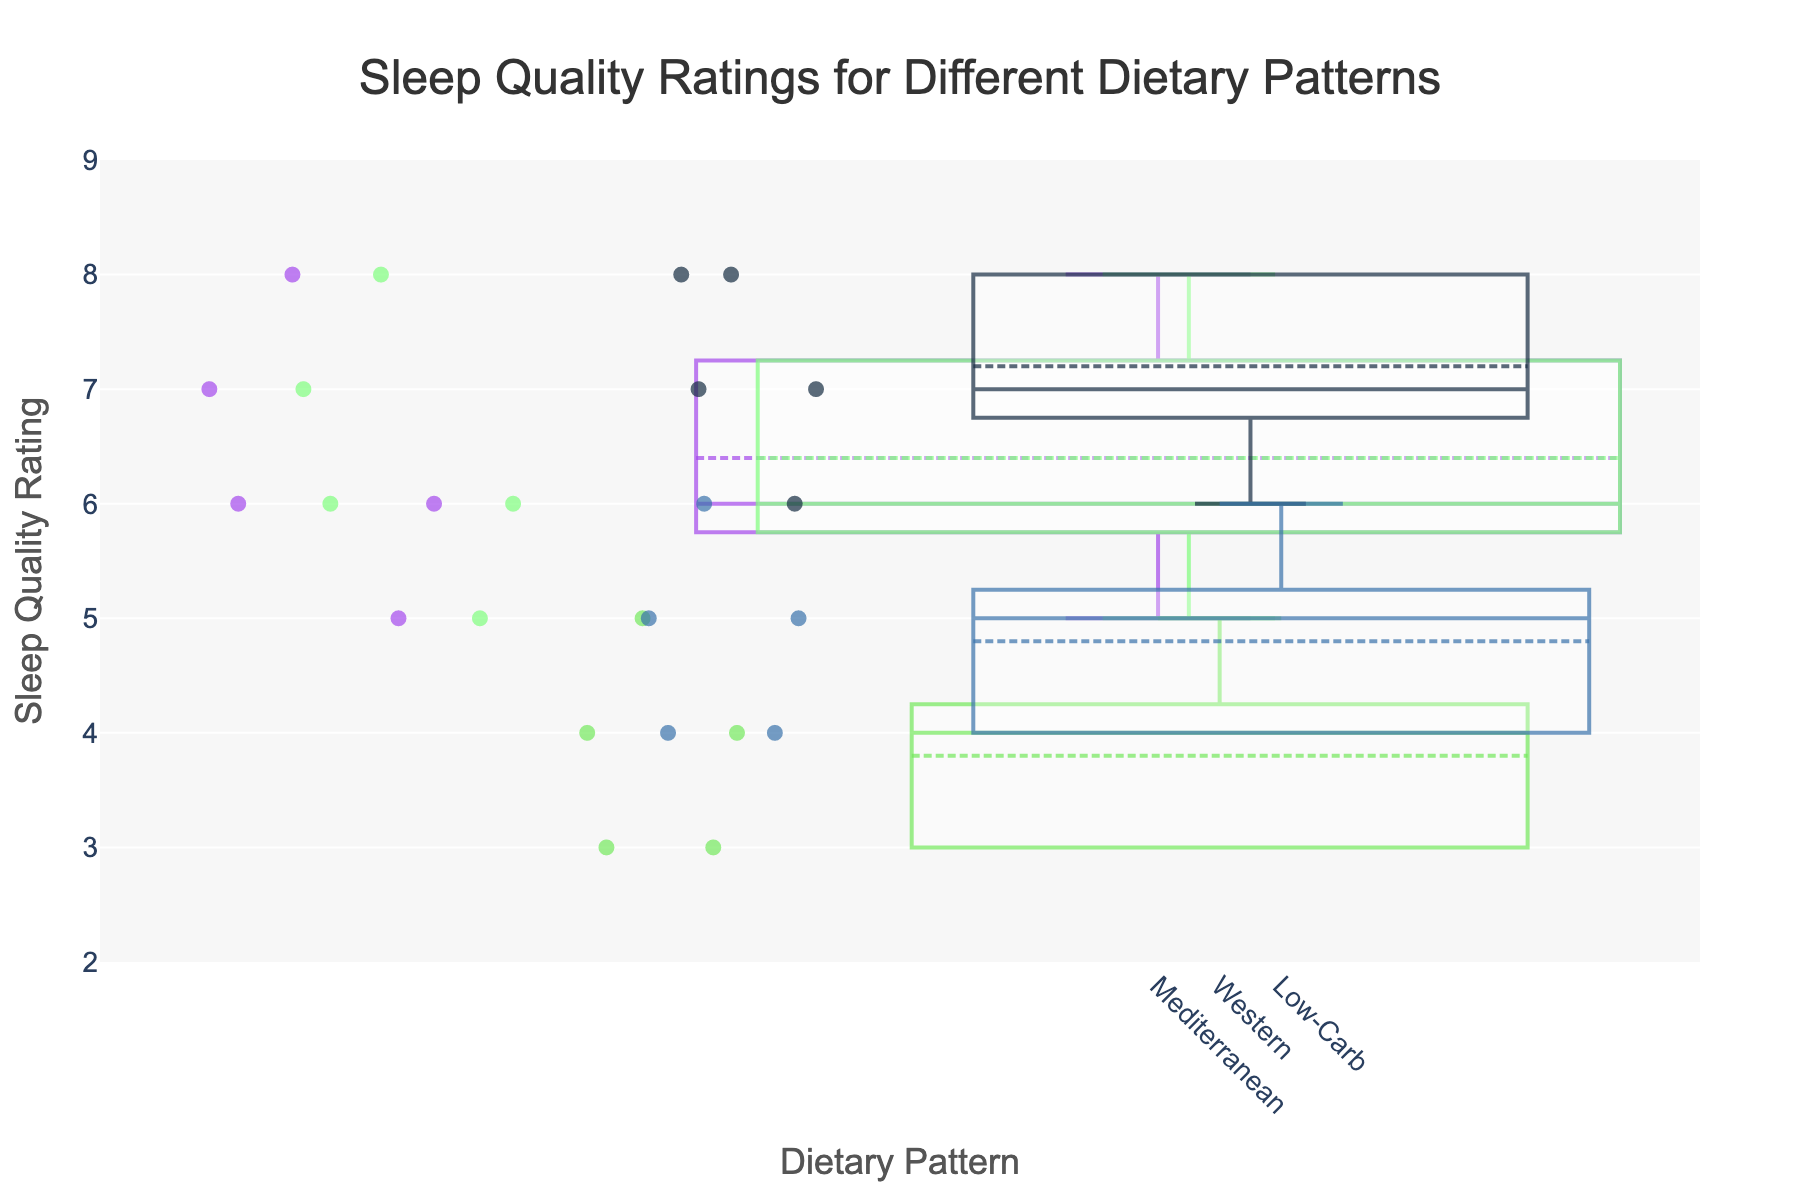Which dietary pattern has the highest median sleep quality rating? To determine the highest median sleep quality rating, look for the box plot whose central line (median) is highest on the y-axis.
Answer: DASH How many sleep quality ratings are there for the Western dietary pattern? Identify by counting the data points (circle markers) shown in the box plot for the Western dietary pattern.
Answer: 5 What is the range of sleep quality ratings for the Low-Carb dietary pattern? The range is found by subtracting the minimum sleep quality rating from the maximum rating within the Low-Carb plot.
Answer: 4 - 6 Which dietary pattern shows the highest variability in sleep quality ratings? The highest variability can be assessed by looking at the length of the box plot's whiskers and the spread of data points. The Western dietary pattern has longer whiskers and more spread-out points.
Answer: Western Compared to the Mediterranean diet, is the median sleep quality rating for the Vegetarian diet higher or lower? Compare the central line (median) positions of both the Mediterranean and Vegetarian box plots on the y-axis. The central line for the Vegetarian box plot is slightly higher.
Answer: Higher What is the median sleep quality rating for the Mediterranean dietary pattern? Look for the black line in the center of the Mediterranean box plot, which represents the median value. It's marked at 6.5.
Answer: 6.5 Which dietary pattern has the narrowest width in its box plot and what might this width indicate? The Mediterranean dietary pattern has the narrowest width. Narrower widths generally indicate a smaller range in sleep duration among participants in that group.
Answer: Mediterranean On which dietary pattern does the interquartile range (IQR) of the sleep quality ratings span from 5 to 8? The interquartile range is represented by the box portion of the plot. For the DASH dietary pattern, the IQR spans from 6 to 8, which is not quite fitting the required range. The correct pattern, given the plot width considerations, is the Vegetarian diet.
Answer: Vegetarian What is the average sleep duration for the DASH dietary pattern if it tends to sleep between 7.3 to 8.0 hours? Add the reference values of sleep durations given as 7.3, 8.1, 7.5, 7.2, and 8.0, then divide the sum by 5.
Answer: 7.62 How does the sleep quality rating for the Western diet compare to the Mediterranean diet in terms of overall distribution? By examining the box plots, the Western diet has lower sleep quality ratings with a median at 4, while the Mediterranean diet has a median sleep quality rating near 6.5, and generally falls in the middle or higher end of the rating scale.
Answer: Western ratings are lower 